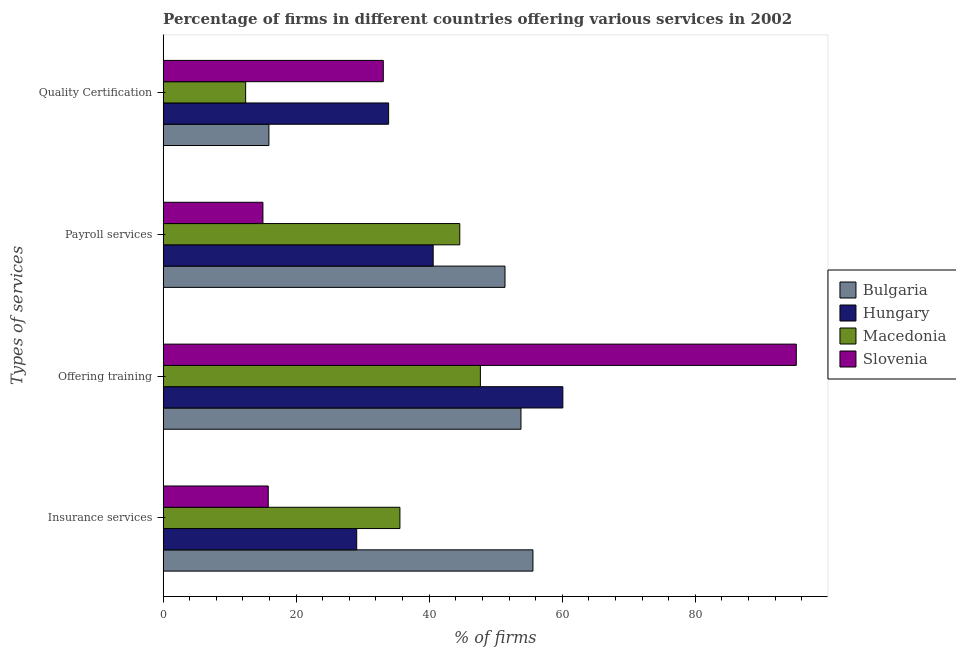Are the number of bars per tick equal to the number of legend labels?
Keep it short and to the point. Yes. Are the number of bars on each tick of the Y-axis equal?
Offer a very short reply. Yes. What is the label of the 3rd group of bars from the top?
Give a very brief answer. Offering training. What is the percentage of firms offering quality certification in Bulgaria?
Make the answer very short. 15.9. Across all countries, what is the maximum percentage of firms offering training?
Keep it short and to the point. 95.2. In which country was the percentage of firms offering payroll services maximum?
Your response must be concise. Bulgaria. In which country was the percentage of firms offering insurance services minimum?
Provide a succinct answer. Slovenia. What is the total percentage of firms offering quality certification in the graph?
Offer a very short reply. 95.3. What is the difference between the percentage of firms offering payroll services in Hungary and that in Macedonia?
Offer a very short reply. -4. What is the difference between the percentage of firms offering payroll services in Bulgaria and the percentage of firms offering insurance services in Hungary?
Keep it short and to the point. 22.3. What is the average percentage of firms offering quality certification per country?
Give a very brief answer. 23.82. What is the difference between the percentage of firms offering training and percentage of firms offering insurance services in Hungary?
Keep it short and to the point. 31. What is the ratio of the percentage of firms offering training in Bulgaria to that in Hungary?
Keep it short and to the point. 0.9. What is the difference between the highest and the second highest percentage of firms offering training?
Your answer should be compact. 35.1. What is the difference between the highest and the lowest percentage of firms offering training?
Ensure brevity in your answer.  47.5. In how many countries, is the percentage of firms offering training greater than the average percentage of firms offering training taken over all countries?
Provide a short and direct response. 1. What does the 4th bar from the top in Offering training represents?
Offer a terse response. Bulgaria. What does the 3rd bar from the bottom in Insurance services represents?
Your answer should be compact. Macedonia. Is it the case that in every country, the sum of the percentage of firms offering insurance services and percentage of firms offering training is greater than the percentage of firms offering payroll services?
Ensure brevity in your answer.  Yes. How many bars are there?
Your response must be concise. 16. How many countries are there in the graph?
Make the answer very short. 4. What is the difference between two consecutive major ticks on the X-axis?
Provide a succinct answer. 20. Are the values on the major ticks of X-axis written in scientific E-notation?
Make the answer very short. No. Where does the legend appear in the graph?
Provide a short and direct response. Center right. How many legend labels are there?
Offer a terse response. 4. What is the title of the graph?
Provide a short and direct response. Percentage of firms in different countries offering various services in 2002. What is the label or title of the X-axis?
Provide a succinct answer. % of firms. What is the label or title of the Y-axis?
Give a very brief answer. Types of services. What is the % of firms of Bulgaria in Insurance services?
Your answer should be very brief. 55.6. What is the % of firms in Hungary in Insurance services?
Ensure brevity in your answer.  29.1. What is the % of firms in Macedonia in Insurance services?
Provide a short and direct response. 35.6. What is the % of firms of Bulgaria in Offering training?
Make the answer very short. 53.8. What is the % of firms in Hungary in Offering training?
Offer a terse response. 60.1. What is the % of firms in Macedonia in Offering training?
Make the answer very short. 47.7. What is the % of firms in Slovenia in Offering training?
Keep it short and to the point. 95.2. What is the % of firms of Bulgaria in Payroll services?
Your answer should be very brief. 51.4. What is the % of firms in Hungary in Payroll services?
Offer a terse response. 40.6. What is the % of firms in Macedonia in Payroll services?
Offer a terse response. 44.6. What is the % of firms in Hungary in Quality Certification?
Provide a short and direct response. 33.9. What is the % of firms in Macedonia in Quality Certification?
Keep it short and to the point. 12.4. What is the % of firms of Slovenia in Quality Certification?
Give a very brief answer. 33.1. Across all Types of services, what is the maximum % of firms in Bulgaria?
Ensure brevity in your answer.  55.6. Across all Types of services, what is the maximum % of firms of Hungary?
Give a very brief answer. 60.1. Across all Types of services, what is the maximum % of firms in Macedonia?
Offer a terse response. 47.7. Across all Types of services, what is the maximum % of firms in Slovenia?
Keep it short and to the point. 95.2. Across all Types of services, what is the minimum % of firms in Bulgaria?
Offer a very short reply. 15.9. Across all Types of services, what is the minimum % of firms in Hungary?
Your answer should be very brief. 29.1. Across all Types of services, what is the minimum % of firms in Macedonia?
Your answer should be very brief. 12.4. Across all Types of services, what is the minimum % of firms of Slovenia?
Keep it short and to the point. 15. What is the total % of firms of Bulgaria in the graph?
Provide a succinct answer. 176.7. What is the total % of firms of Hungary in the graph?
Make the answer very short. 163.7. What is the total % of firms of Macedonia in the graph?
Give a very brief answer. 140.3. What is the total % of firms of Slovenia in the graph?
Make the answer very short. 159.1. What is the difference between the % of firms of Bulgaria in Insurance services and that in Offering training?
Ensure brevity in your answer.  1.8. What is the difference between the % of firms of Hungary in Insurance services and that in Offering training?
Offer a very short reply. -31. What is the difference between the % of firms in Macedonia in Insurance services and that in Offering training?
Your response must be concise. -12.1. What is the difference between the % of firms in Slovenia in Insurance services and that in Offering training?
Provide a short and direct response. -79.4. What is the difference between the % of firms of Bulgaria in Insurance services and that in Payroll services?
Ensure brevity in your answer.  4.2. What is the difference between the % of firms in Macedonia in Insurance services and that in Payroll services?
Provide a succinct answer. -9. What is the difference between the % of firms in Slovenia in Insurance services and that in Payroll services?
Provide a short and direct response. 0.8. What is the difference between the % of firms in Bulgaria in Insurance services and that in Quality Certification?
Ensure brevity in your answer.  39.7. What is the difference between the % of firms in Hungary in Insurance services and that in Quality Certification?
Offer a very short reply. -4.8. What is the difference between the % of firms of Macedonia in Insurance services and that in Quality Certification?
Make the answer very short. 23.2. What is the difference between the % of firms of Slovenia in Insurance services and that in Quality Certification?
Your answer should be compact. -17.3. What is the difference between the % of firms in Hungary in Offering training and that in Payroll services?
Provide a short and direct response. 19.5. What is the difference between the % of firms in Macedonia in Offering training and that in Payroll services?
Make the answer very short. 3.1. What is the difference between the % of firms of Slovenia in Offering training and that in Payroll services?
Make the answer very short. 80.2. What is the difference between the % of firms of Bulgaria in Offering training and that in Quality Certification?
Your answer should be very brief. 37.9. What is the difference between the % of firms of Hungary in Offering training and that in Quality Certification?
Make the answer very short. 26.2. What is the difference between the % of firms in Macedonia in Offering training and that in Quality Certification?
Your answer should be very brief. 35.3. What is the difference between the % of firms in Slovenia in Offering training and that in Quality Certification?
Ensure brevity in your answer.  62.1. What is the difference between the % of firms of Bulgaria in Payroll services and that in Quality Certification?
Your answer should be compact. 35.5. What is the difference between the % of firms of Hungary in Payroll services and that in Quality Certification?
Ensure brevity in your answer.  6.7. What is the difference between the % of firms of Macedonia in Payroll services and that in Quality Certification?
Provide a short and direct response. 32.2. What is the difference between the % of firms of Slovenia in Payroll services and that in Quality Certification?
Offer a terse response. -18.1. What is the difference between the % of firms of Bulgaria in Insurance services and the % of firms of Hungary in Offering training?
Offer a very short reply. -4.5. What is the difference between the % of firms in Bulgaria in Insurance services and the % of firms in Slovenia in Offering training?
Offer a terse response. -39.6. What is the difference between the % of firms in Hungary in Insurance services and the % of firms in Macedonia in Offering training?
Offer a terse response. -18.6. What is the difference between the % of firms in Hungary in Insurance services and the % of firms in Slovenia in Offering training?
Ensure brevity in your answer.  -66.1. What is the difference between the % of firms in Macedonia in Insurance services and the % of firms in Slovenia in Offering training?
Your answer should be very brief. -59.6. What is the difference between the % of firms in Bulgaria in Insurance services and the % of firms in Hungary in Payroll services?
Offer a very short reply. 15. What is the difference between the % of firms in Bulgaria in Insurance services and the % of firms in Macedonia in Payroll services?
Keep it short and to the point. 11. What is the difference between the % of firms of Bulgaria in Insurance services and the % of firms of Slovenia in Payroll services?
Ensure brevity in your answer.  40.6. What is the difference between the % of firms in Hungary in Insurance services and the % of firms in Macedonia in Payroll services?
Offer a terse response. -15.5. What is the difference between the % of firms of Hungary in Insurance services and the % of firms of Slovenia in Payroll services?
Your response must be concise. 14.1. What is the difference between the % of firms of Macedonia in Insurance services and the % of firms of Slovenia in Payroll services?
Ensure brevity in your answer.  20.6. What is the difference between the % of firms in Bulgaria in Insurance services and the % of firms in Hungary in Quality Certification?
Keep it short and to the point. 21.7. What is the difference between the % of firms in Bulgaria in Insurance services and the % of firms in Macedonia in Quality Certification?
Make the answer very short. 43.2. What is the difference between the % of firms in Hungary in Insurance services and the % of firms in Slovenia in Quality Certification?
Provide a succinct answer. -4. What is the difference between the % of firms of Bulgaria in Offering training and the % of firms of Slovenia in Payroll services?
Provide a succinct answer. 38.8. What is the difference between the % of firms in Hungary in Offering training and the % of firms in Slovenia in Payroll services?
Your response must be concise. 45.1. What is the difference between the % of firms in Macedonia in Offering training and the % of firms in Slovenia in Payroll services?
Keep it short and to the point. 32.7. What is the difference between the % of firms in Bulgaria in Offering training and the % of firms in Macedonia in Quality Certification?
Provide a succinct answer. 41.4. What is the difference between the % of firms in Bulgaria in Offering training and the % of firms in Slovenia in Quality Certification?
Your answer should be compact. 20.7. What is the difference between the % of firms of Hungary in Offering training and the % of firms of Macedonia in Quality Certification?
Provide a succinct answer. 47.7. What is the difference between the % of firms in Hungary in Offering training and the % of firms in Slovenia in Quality Certification?
Ensure brevity in your answer.  27. What is the difference between the % of firms of Bulgaria in Payroll services and the % of firms of Hungary in Quality Certification?
Give a very brief answer. 17.5. What is the difference between the % of firms in Bulgaria in Payroll services and the % of firms in Macedonia in Quality Certification?
Offer a very short reply. 39. What is the difference between the % of firms of Hungary in Payroll services and the % of firms of Macedonia in Quality Certification?
Offer a very short reply. 28.2. What is the average % of firms in Bulgaria per Types of services?
Keep it short and to the point. 44.17. What is the average % of firms in Hungary per Types of services?
Make the answer very short. 40.92. What is the average % of firms in Macedonia per Types of services?
Your response must be concise. 35.08. What is the average % of firms of Slovenia per Types of services?
Make the answer very short. 39.77. What is the difference between the % of firms in Bulgaria and % of firms in Hungary in Insurance services?
Ensure brevity in your answer.  26.5. What is the difference between the % of firms in Bulgaria and % of firms in Macedonia in Insurance services?
Offer a very short reply. 20. What is the difference between the % of firms of Bulgaria and % of firms of Slovenia in Insurance services?
Provide a succinct answer. 39.8. What is the difference between the % of firms of Macedonia and % of firms of Slovenia in Insurance services?
Make the answer very short. 19.8. What is the difference between the % of firms of Bulgaria and % of firms of Hungary in Offering training?
Your answer should be compact. -6.3. What is the difference between the % of firms in Bulgaria and % of firms in Slovenia in Offering training?
Keep it short and to the point. -41.4. What is the difference between the % of firms of Hungary and % of firms of Macedonia in Offering training?
Your answer should be very brief. 12.4. What is the difference between the % of firms of Hungary and % of firms of Slovenia in Offering training?
Provide a succinct answer. -35.1. What is the difference between the % of firms in Macedonia and % of firms in Slovenia in Offering training?
Provide a succinct answer. -47.5. What is the difference between the % of firms in Bulgaria and % of firms in Slovenia in Payroll services?
Offer a terse response. 36.4. What is the difference between the % of firms in Hungary and % of firms in Macedonia in Payroll services?
Offer a terse response. -4. What is the difference between the % of firms in Hungary and % of firms in Slovenia in Payroll services?
Keep it short and to the point. 25.6. What is the difference between the % of firms in Macedonia and % of firms in Slovenia in Payroll services?
Offer a terse response. 29.6. What is the difference between the % of firms in Bulgaria and % of firms in Hungary in Quality Certification?
Keep it short and to the point. -18. What is the difference between the % of firms of Bulgaria and % of firms of Slovenia in Quality Certification?
Make the answer very short. -17.2. What is the difference between the % of firms of Hungary and % of firms of Slovenia in Quality Certification?
Make the answer very short. 0.8. What is the difference between the % of firms of Macedonia and % of firms of Slovenia in Quality Certification?
Offer a terse response. -20.7. What is the ratio of the % of firms in Bulgaria in Insurance services to that in Offering training?
Provide a short and direct response. 1.03. What is the ratio of the % of firms of Hungary in Insurance services to that in Offering training?
Keep it short and to the point. 0.48. What is the ratio of the % of firms in Macedonia in Insurance services to that in Offering training?
Ensure brevity in your answer.  0.75. What is the ratio of the % of firms of Slovenia in Insurance services to that in Offering training?
Offer a very short reply. 0.17. What is the ratio of the % of firms of Bulgaria in Insurance services to that in Payroll services?
Provide a succinct answer. 1.08. What is the ratio of the % of firms of Hungary in Insurance services to that in Payroll services?
Offer a very short reply. 0.72. What is the ratio of the % of firms in Macedonia in Insurance services to that in Payroll services?
Provide a short and direct response. 0.8. What is the ratio of the % of firms in Slovenia in Insurance services to that in Payroll services?
Your response must be concise. 1.05. What is the ratio of the % of firms in Bulgaria in Insurance services to that in Quality Certification?
Provide a succinct answer. 3.5. What is the ratio of the % of firms in Hungary in Insurance services to that in Quality Certification?
Provide a succinct answer. 0.86. What is the ratio of the % of firms of Macedonia in Insurance services to that in Quality Certification?
Make the answer very short. 2.87. What is the ratio of the % of firms of Slovenia in Insurance services to that in Quality Certification?
Keep it short and to the point. 0.48. What is the ratio of the % of firms in Bulgaria in Offering training to that in Payroll services?
Your answer should be compact. 1.05. What is the ratio of the % of firms in Hungary in Offering training to that in Payroll services?
Your response must be concise. 1.48. What is the ratio of the % of firms in Macedonia in Offering training to that in Payroll services?
Your response must be concise. 1.07. What is the ratio of the % of firms in Slovenia in Offering training to that in Payroll services?
Ensure brevity in your answer.  6.35. What is the ratio of the % of firms of Bulgaria in Offering training to that in Quality Certification?
Provide a short and direct response. 3.38. What is the ratio of the % of firms of Hungary in Offering training to that in Quality Certification?
Give a very brief answer. 1.77. What is the ratio of the % of firms of Macedonia in Offering training to that in Quality Certification?
Provide a succinct answer. 3.85. What is the ratio of the % of firms of Slovenia in Offering training to that in Quality Certification?
Your response must be concise. 2.88. What is the ratio of the % of firms in Bulgaria in Payroll services to that in Quality Certification?
Ensure brevity in your answer.  3.23. What is the ratio of the % of firms of Hungary in Payroll services to that in Quality Certification?
Offer a very short reply. 1.2. What is the ratio of the % of firms in Macedonia in Payroll services to that in Quality Certification?
Offer a terse response. 3.6. What is the ratio of the % of firms of Slovenia in Payroll services to that in Quality Certification?
Give a very brief answer. 0.45. What is the difference between the highest and the second highest % of firms in Macedonia?
Provide a succinct answer. 3.1. What is the difference between the highest and the second highest % of firms of Slovenia?
Offer a terse response. 62.1. What is the difference between the highest and the lowest % of firms of Bulgaria?
Your response must be concise. 39.7. What is the difference between the highest and the lowest % of firms in Hungary?
Your response must be concise. 31. What is the difference between the highest and the lowest % of firms of Macedonia?
Ensure brevity in your answer.  35.3. What is the difference between the highest and the lowest % of firms in Slovenia?
Your answer should be very brief. 80.2. 